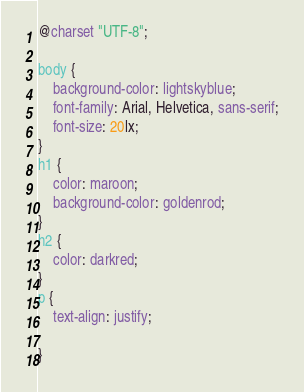Convert code to text. <code><loc_0><loc_0><loc_500><loc_500><_CSS_>@charset "UTF-8";

body { 
    background-color: lightskyblue;
    font-family: Arial, Helvetica, sans-serif;
    font-size: 20lx;
}
h1 {
    color: maroon;
    background-color: goldenrod;
}
h2 {
    color: darkred;
}
p {
    text-align: justify;
    
}</code> 